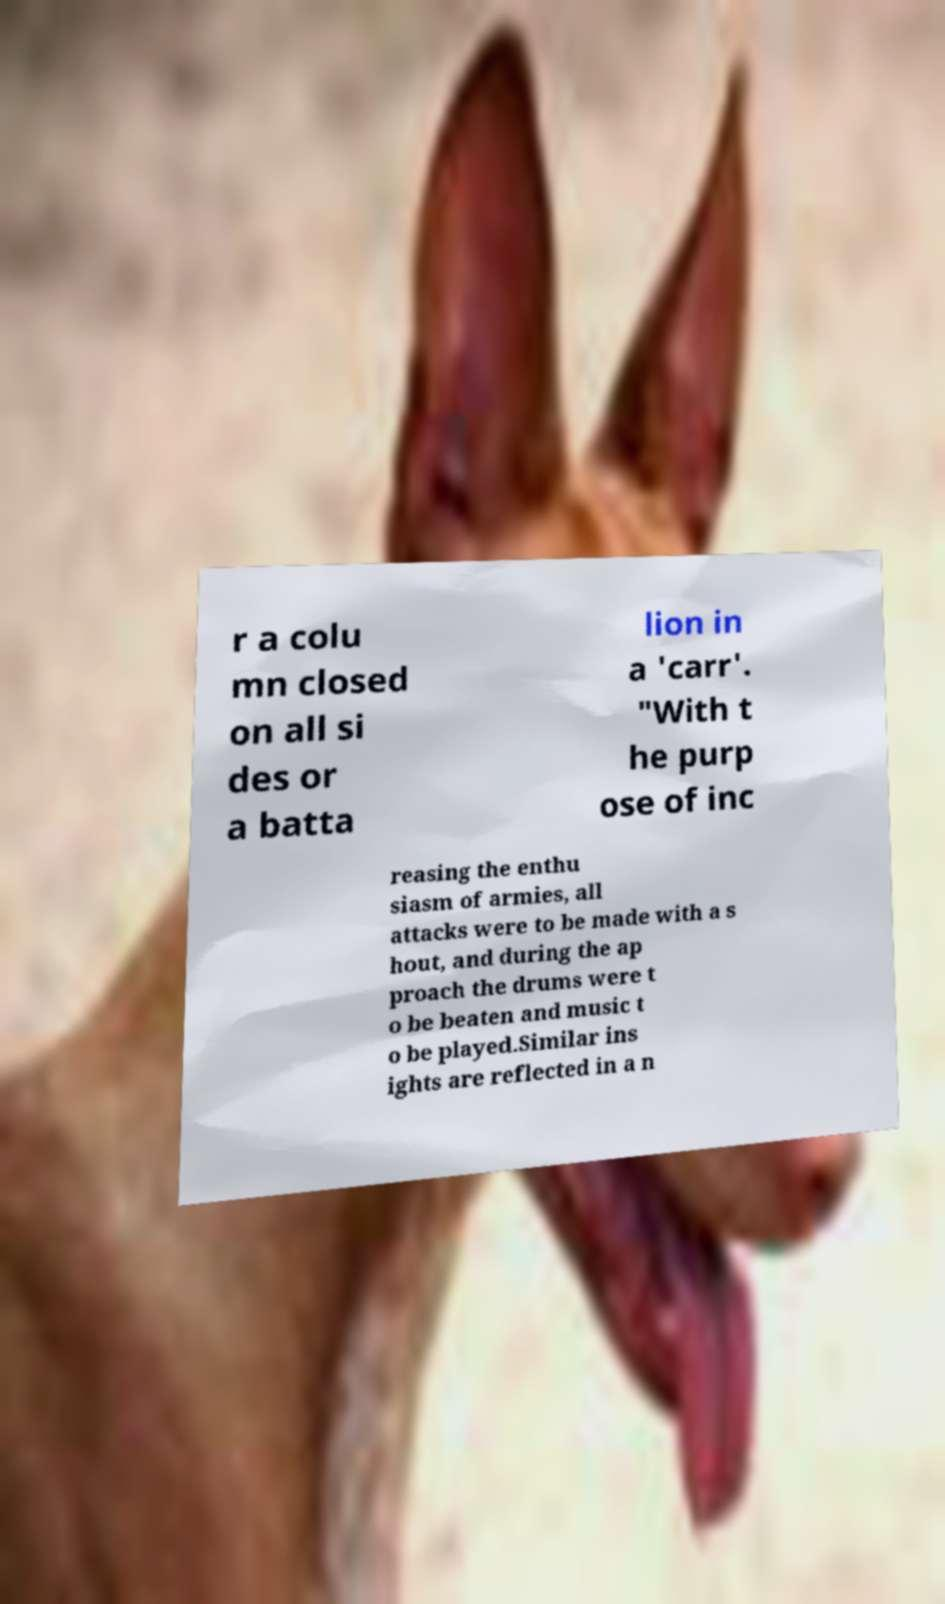For documentation purposes, I need the text within this image transcribed. Could you provide that? r a colu mn closed on all si des or a batta lion in a 'carr'. "With t he purp ose of inc reasing the enthu siasm of armies, all attacks were to be made with a s hout, and during the ap proach the drums were t o be beaten and music t o be played.Similar ins ights are reflected in a n 